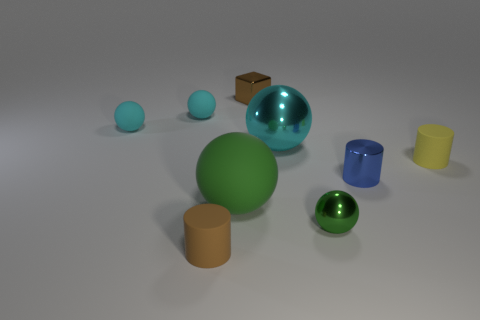What is the size of the cyan metal sphere?
Your answer should be compact. Large. Is the material of the tiny brown block the same as the small brown object on the left side of the large rubber ball?
Your answer should be very brief. No. Are there any yellow matte objects of the same shape as the large cyan shiny object?
Give a very brief answer. No. What material is the green ball that is the same size as the brown matte thing?
Your answer should be compact. Metal. There is a shiny sphere in front of the yellow rubber thing; what size is it?
Provide a short and direct response. Small. There is a brown object behind the blue thing; is it the same size as the matte cylinder on the right side of the small shiny block?
Give a very brief answer. Yes. What number of tiny things are the same material as the brown cylinder?
Provide a succinct answer. 3. The small cube is what color?
Your response must be concise. Brown. Are there any tiny matte things to the right of the large metallic object?
Your answer should be very brief. Yes. Do the large rubber thing and the large shiny ball have the same color?
Your answer should be compact. No. 